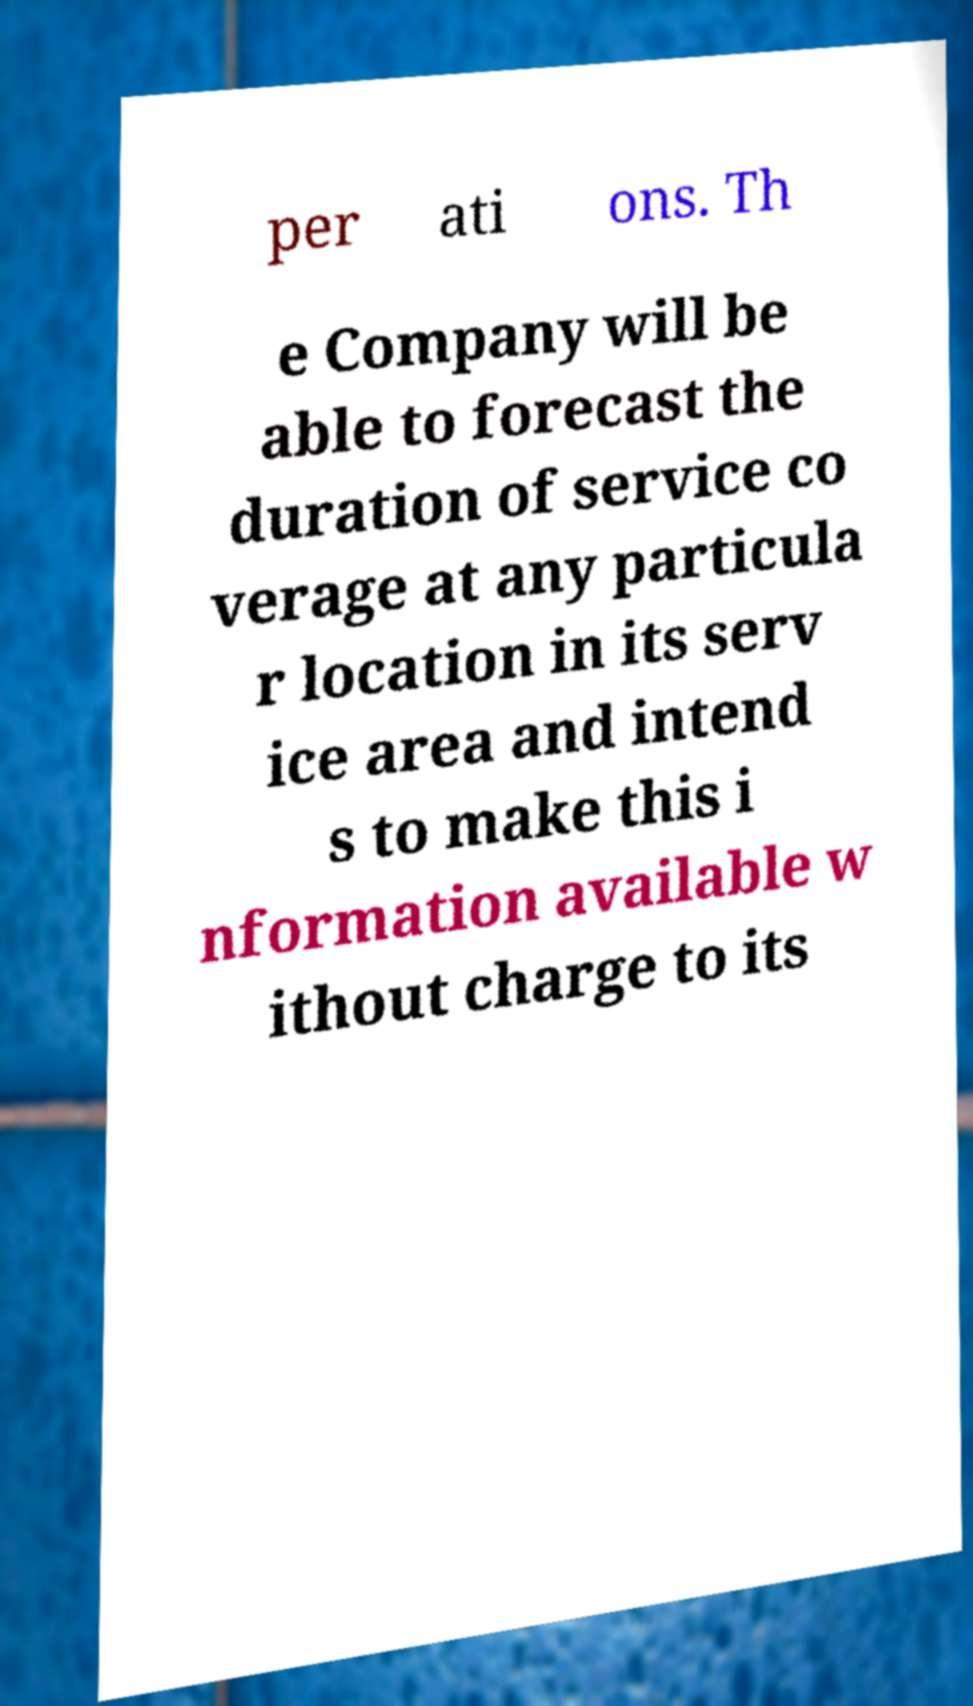Please read and relay the text visible in this image. What does it say? per ati ons. Th e Company will be able to forecast the duration of service co verage at any particula r location in its serv ice area and intend s to make this i nformation available w ithout charge to its 